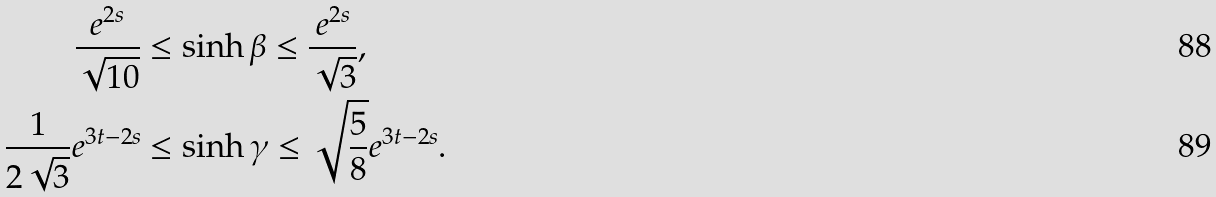Convert formula to latex. <formula><loc_0><loc_0><loc_500><loc_500>\frac { e ^ { 2 s } } { \sqrt { 1 0 } } & \leq \sinh \beta \leq \frac { e ^ { 2 s } } { \sqrt { 3 } } , \\ \frac { 1 } { 2 \sqrt { 3 } } e ^ { 3 t - 2 s } & \leq \sinh \gamma \leq \sqrt { \frac { 5 } { 8 } } e ^ { 3 t - 2 s } .</formula> 